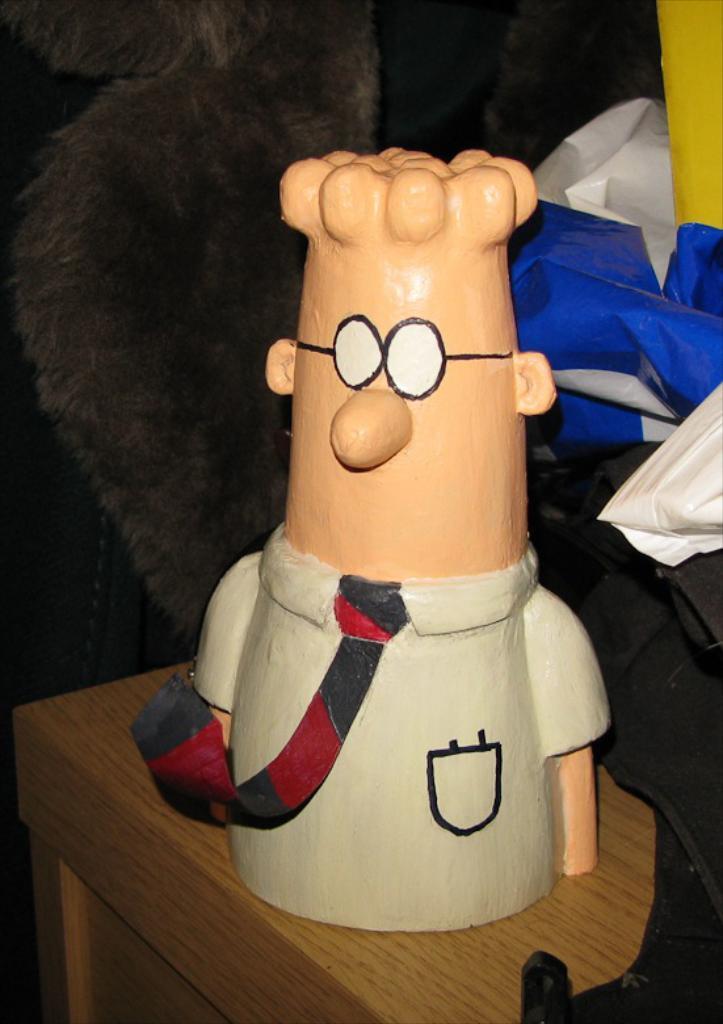Please provide a concise description of this image. In this image I can see a toy, I can see colour of this toy is cream, white, black and red. In the background I can see a blue colour thing, a yellow colour thing and few white colour things. 